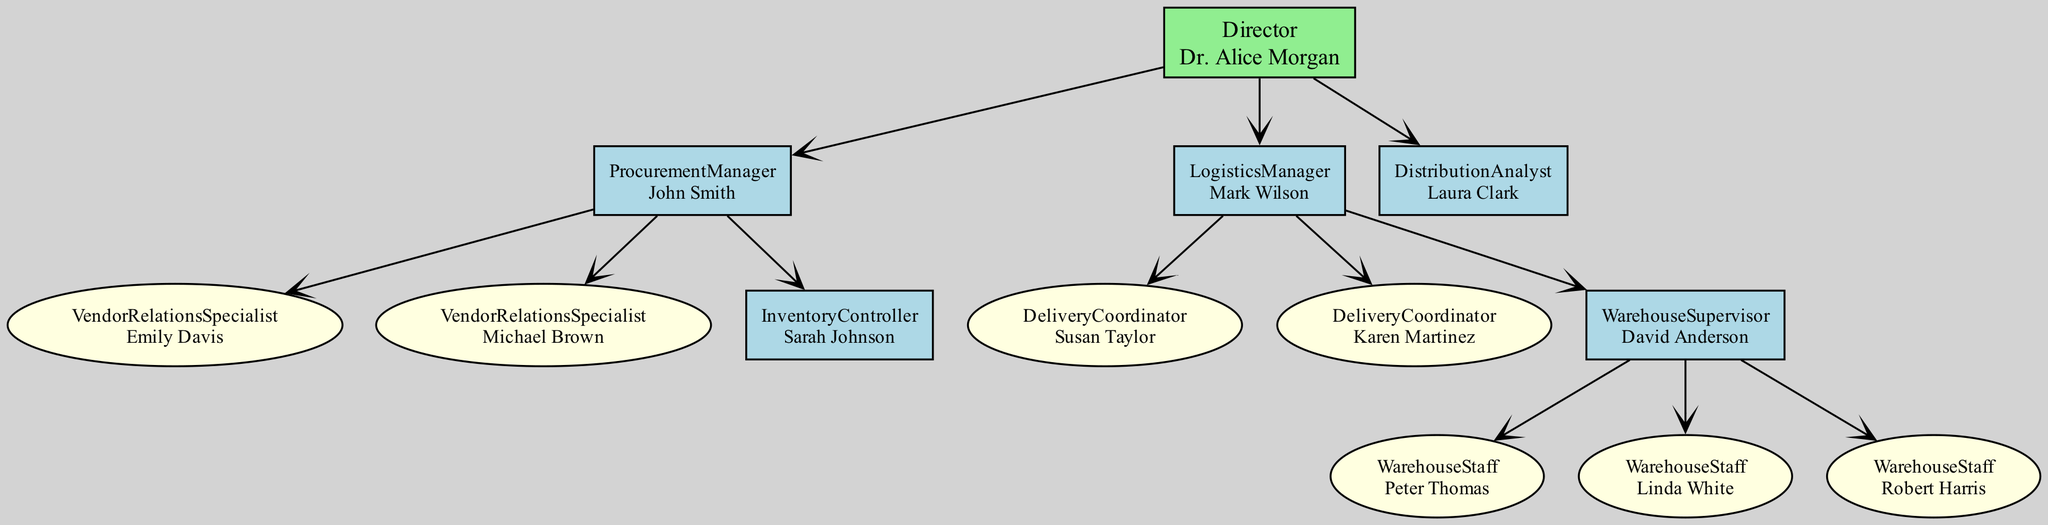What is the name of the Director in the Health Department? The Director in the Health Department is identified as "Dr. Alice Morgan" in the diagram. This pertains to the node directly under the "HealthDepartment" node.
Answer: Dr. Alice Morgan How many roles report directly to the Director? Upon examining the diagram, three roles can be seen branching directly from the Director node: Procurement Manager, Logistics Manager, and Distribution Analyst. Counting these gives a total of three roles.
Answer: 3 Who is the Inventory Controller? The Inventory Controller is denoted as "Sarah Johnson" in the diagram, being part of the Procurement Manager’s team. The node under "ProcurementManager" indicates her as the team member.
Answer: Sarah Johnson How many Delivery Coordinators are there? The diagram shows two individuals listed as Delivery Coordinators: "Susan Taylor" and "Karen Martinez". Counting those gives a total of two Delivery Coordinators.
Answer: 2 Which role oversees the Warehouse Supervisor? The Warehouse Supervisor is overseen by the Logistics Manager as depicted in the diagram. This is inferred from the hierarchical structure where the Logistics Manager node directly connects to the Warehouse Supervisor node.
Answer: Logistics Manager List the names of the Vendor Relations Specialists. The Vendor Relations Specialists, as shown in the diagram, are "Emily Davis" and "Michael Brown". These names can be found under the Procurement Manager's team section.
Answer: Emily Davis, Michael Brown How many individuals are part of the Warehouse Staff? The diagram indicates there are three individuals listed under Warehouse Staff: "Peter Thomas", "Linda White", and "Robert Harris". Counting these names results in a total of three individuals.
Answer: 3 Which position is responsible for analyzing distribution? The position responsible for analyzing distribution is titled "Distribution Analyst", and the name associated with this role is "Laura Clark", as seen in the diagram under the Director's team.
Answer: Distribution Analyst Who reports to the Procurement Manager? Two individuals report to the Procurement Manager: the Vendor Relations Specialists (Emily Davis and Michael Brown) and the Inventory Controller (Sarah Johnson). This complexity of teams indicates multiple reports.
Answer: Vendor Relations Specialists and Inventory Controller 